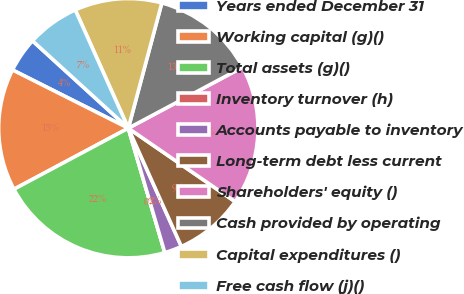Convert chart. <chart><loc_0><loc_0><loc_500><loc_500><pie_chart><fcel>Years ended December 31<fcel>Working capital (g)()<fcel>Total assets (g)()<fcel>Inventory turnover (h)<fcel>Accounts payable to inventory<fcel>Long-term debt less current<fcel>Shareholders' equity ()<fcel>Cash provided by operating<fcel>Capital expenditures ()<fcel>Free cash flow (j)()<nl><fcel>4.35%<fcel>15.22%<fcel>21.74%<fcel>0.0%<fcel>2.17%<fcel>8.7%<fcel>17.39%<fcel>13.04%<fcel>10.87%<fcel>6.52%<nl></chart> 